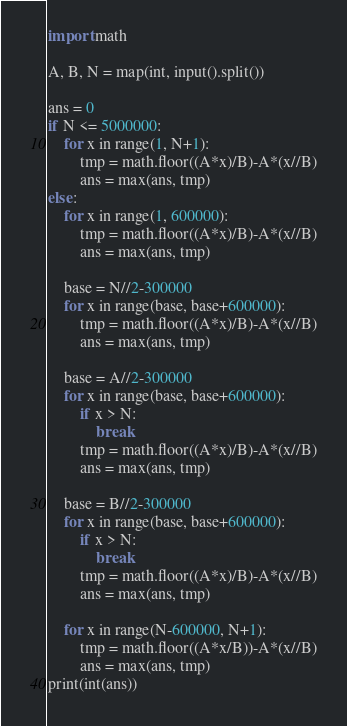<code> <loc_0><loc_0><loc_500><loc_500><_Python_>import math

A, B, N = map(int, input().split())

ans = 0
if N <= 5000000:
    for x in range(1, N+1):
        tmp = math.floor((A*x)/B)-A*(x//B)
        ans = max(ans, tmp)
else:
    for x in range(1, 600000):
        tmp = math.floor((A*x)/B)-A*(x//B)
        ans = max(ans, tmp)

    base = N//2-300000
    for x in range(base, base+600000):
        tmp = math.floor((A*x)/B)-A*(x//B)
        ans = max(ans, tmp)

    base = A//2-300000
    for x in range(base, base+600000):
        if x > N:
            break
        tmp = math.floor((A*x)/B)-A*(x//B)
        ans = max(ans, tmp)

    base = B//2-300000
    for x in range(base, base+600000):
        if x > N:
            break
        tmp = math.floor((A*x)/B)-A*(x//B)
        ans = max(ans, tmp)

    for x in range(N-600000, N+1):
        tmp = math.floor((A*x/B))-A*(x//B)
        ans = max(ans, tmp)
print(int(ans))
</code> 